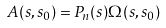Convert formula to latex. <formula><loc_0><loc_0><loc_500><loc_500>A ( s , s _ { 0 } ) = P _ { n } ( s ) \Omega ( s , s _ { 0 } )</formula> 